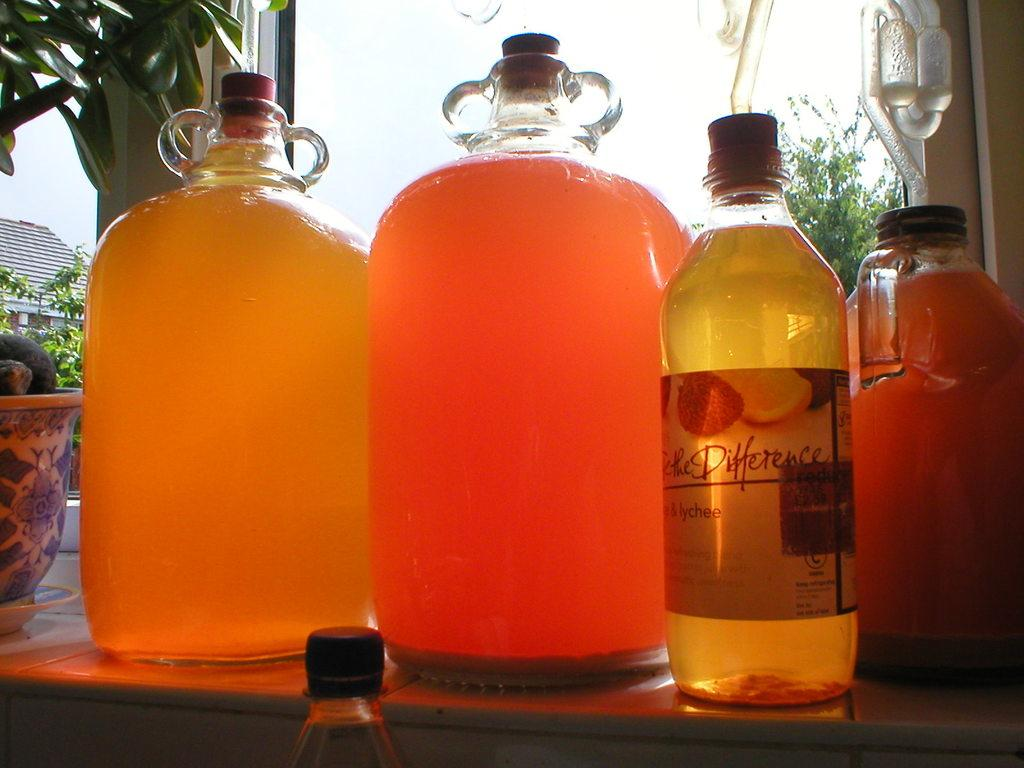What type of containers are visible in the image? There are bottles and glass jars in the image. What type of structure is present in the image? There is a house in the image. What type of vegetation is around the house in the image? There are trees around the house in the image. What type of vacation can be seen taking place at the seashore in the image? There is no seashore or vacation present in the image; it features bottles, glass jars, a house, and trees. How comfortable is the seating arrangement in the image? There is no seating arrangement present in the image, so it is not possible to determine its comfort level. 